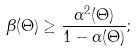Convert formula to latex. <formula><loc_0><loc_0><loc_500><loc_500>\beta ( \Theta ) \geq \frac { \alpha ^ { 2 } ( \Theta ) } { 1 - \alpha ( \Theta ) } ;</formula> 